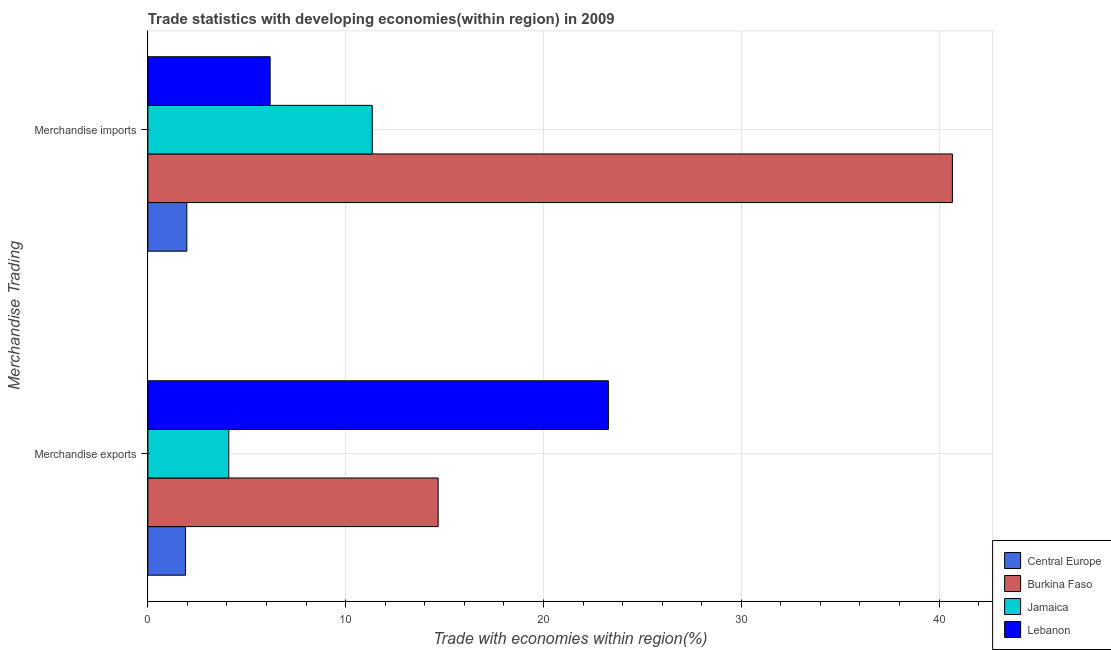How many groups of bars are there?
Offer a very short reply. 2. What is the label of the 1st group of bars from the top?
Keep it short and to the point. Merchandise imports. What is the merchandise exports in Central Europe?
Make the answer very short. 1.9. Across all countries, what is the maximum merchandise imports?
Provide a short and direct response. 40.67. Across all countries, what is the minimum merchandise imports?
Give a very brief answer. 1.97. In which country was the merchandise exports maximum?
Make the answer very short. Lebanon. In which country was the merchandise exports minimum?
Your response must be concise. Central Europe. What is the total merchandise imports in the graph?
Offer a terse response. 60.17. What is the difference between the merchandise exports in Lebanon and that in Central Europe?
Ensure brevity in your answer.  21.38. What is the difference between the merchandise exports in Jamaica and the merchandise imports in Lebanon?
Keep it short and to the point. -2.09. What is the average merchandise exports per country?
Offer a terse response. 10.99. What is the difference between the merchandise exports and merchandise imports in Burkina Faso?
Provide a short and direct response. -26. What is the ratio of the merchandise imports in Jamaica to that in Central Europe?
Your answer should be compact. 5.76. Is the merchandise imports in Jamaica less than that in Central Europe?
Offer a very short reply. No. What does the 2nd bar from the top in Merchandise exports represents?
Offer a terse response. Jamaica. What does the 1st bar from the bottom in Merchandise imports represents?
Your response must be concise. Central Europe. How many bars are there?
Make the answer very short. 8. Are all the bars in the graph horizontal?
Provide a short and direct response. Yes. How many countries are there in the graph?
Ensure brevity in your answer.  4. Does the graph contain grids?
Your answer should be compact. Yes. How many legend labels are there?
Your answer should be very brief. 4. What is the title of the graph?
Your answer should be compact. Trade statistics with developing economies(within region) in 2009. What is the label or title of the X-axis?
Give a very brief answer. Trade with economies within region(%). What is the label or title of the Y-axis?
Give a very brief answer. Merchandise Trading. What is the Trade with economies within region(%) in Central Europe in Merchandise exports?
Your answer should be very brief. 1.9. What is the Trade with economies within region(%) in Burkina Faso in Merchandise exports?
Ensure brevity in your answer.  14.67. What is the Trade with economies within region(%) of Jamaica in Merchandise exports?
Your answer should be very brief. 4.09. What is the Trade with economies within region(%) of Lebanon in Merchandise exports?
Make the answer very short. 23.28. What is the Trade with economies within region(%) of Central Europe in Merchandise imports?
Keep it short and to the point. 1.97. What is the Trade with economies within region(%) of Burkina Faso in Merchandise imports?
Ensure brevity in your answer.  40.67. What is the Trade with economies within region(%) in Jamaica in Merchandise imports?
Provide a succinct answer. 11.34. What is the Trade with economies within region(%) in Lebanon in Merchandise imports?
Give a very brief answer. 6.18. Across all Merchandise Trading, what is the maximum Trade with economies within region(%) in Central Europe?
Make the answer very short. 1.97. Across all Merchandise Trading, what is the maximum Trade with economies within region(%) of Burkina Faso?
Your answer should be very brief. 40.67. Across all Merchandise Trading, what is the maximum Trade with economies within region(%) of Jamaica?
Offer a very short reply. 11.34. Across all Merchandise Trading, what is the maximum Trade with economies within region(%) in Lebanon?
Offer a terse response. 23.28. Across all Merchandise Trading, what is the minimum Trade with economies within region(%) of Central Europe?
Give a very brief answer. 1.9. Across all Merchandise Trading, what is the minimum Trade with economies within region(%) of Burkina Faso?
Provide a short and direct response. 14.67. Across all Merchandise Trading, what is the minimum Trade with economies within region(%) in Jamaica?
Provide a succinct answer. 4.09. Across all Merchandise Trading, what is the minimum Trade with economies within region(%) in Lebanon?
Make the answer very short. 6.18. What is the total Trade with economies within region(%) in Central Europe in the graph?
Keep it short and to the point. 3.87. What is the total Trade with economies within region(%) in Burkina Faso in the graph?
Provide a short and direct response. 55.35. What is the total Trade with economies within region(%) in Jamaica in the graph?
Your answer should be very brief. 15.43. What is the total Trade with economies within region(%) of Lebanon in the graph?
Keep it short and to the point. 29.46. What is the difference between the Trade with economies within region(%) in Central Europe in Merchandise exports and that in Merchandise imports?
Make the answer very short. -0.07. What is the difference between the Trade with economies within region(%) in Burkina Faso in Merchandise exports and that in Merchandise imports?
Keep it short and to the point. -26. What is the difference between the Trade with economies within region(%) in Jamaica in Merchandise exports and that in Merchandise imports?
Provide a short and direct response. -7.25. What is the difference between the Trade with economies within region(%) of Lebanon in Merchandise exports and that in Merchandise imports?
Ensure brevity in your answer.  17.1. What is the difference between the Trade with economies within region(%) of Central Europe in Merchandise exports and the Trade with economies within region(%) of Burkina Faso in Merchandise imports?
Provide a succinct answer. -38.77. What is the difference between the Trade with economies within region(%) of Central Europe in Merchandise exports and the Trade with economies within region(%) of Jamaica in Merchandise imports?
Your answer should be very brief. -9.44. What is the difference between the Trade with economies within region(%) of Central Europe in Merchandise exports and the Trade with economies within region(%) of Lebanon in Merchandise imports?
Offer a terse response. -4.28. What is the difference between the Trade with economies within region(%) in Burkina Faso in Merchandise exports and the Trade with economies within region(%) in Jamaica in Merchandise imports?
Your response must be concise. 3.33. What is the difference between the Trade with economies within region(%) of Burkina Faso in Merchandise exports and the Trade with economies within region(%) of Lebanon in Merchandise imports?
Offer a terse response. 8.49. What is the difference between the Trade with economies within region(%) in Jamaica in Merchandise exports and the Trade with economies within region(%) in Lebanon in Merchandise imports?
Your response must be concise. -2.09. What is the average Trade with economies within region(%) of Central Europe per Merchandise Trading?
Give a very brief answer. 1.94. What is the average Trade with economies within region(%) in Burkina Faso per Merchandise Trading?
Give a very brief answer. 27.67. What is the average Trade with economies within region(%) of Jamaica per Merchandise Trading?
Keep it short and to the point. 7.72. What is the average Trade with economies within region(%) of Lebanon per Merchandise Trading?
Give a very brief answer. 14.73. What is the difference between the Trade with economies within region(%) in Central Europe and Trade with economies within region(%) in Burkina Faso in Merchandise exports?
Provide a succinct answer. -12.77. What is the difference between the Trade with economies within region(%) of Central Europe and Trade with economies within region(%) of Jamaica in Merchandise exports?
Offer a terse response. -2.19. What is the difference between the Trade with economies within region(%) of Central Europe and Trade with economies within region(%) of Lebanon in Merchandise exports?
Ensure brevity in your answer.  -21.38. What is the difference between the Trade with economies within region(%) of Burkina Faso and Trade with economies within region(%) of Jamaica in Merchandise exports?
Keep it short and to the point. 10.58. What is the difference between the Trade with economies within region(%) in Burkina Faso and Trade with economies within region(%) in Lebanon in Merchandise exports?
Provide a short and direct response. -8.61. What is the difference between the Trade with economies within region(%) in Jamaica and Trade with economies within region(%) in Lebanon in Merchandise exports?
Give a very brief answer. -19.19. What is the difference between the Trade with economies within region(%) of Central Europe and Trade with economies within region(%) of Burkina Faso in Merchandise imports?
Offer a terse response. -38.71. What is the difference between the Trade with economies within region(%) in Central Europe and Trade with economies within region(%) in Jamaica in Merchandise imports?
Provide a succinct answer. -9.37. What is the difference between the Trade with economies within region(%) in Central Europe and Trade with economies within region(%) in Lebanon in Merchandise imports?
Provide a short and direct response. -4.21. What is the difference between the Trade with economies within region(%) of Burkina Faso and Trade with economies within region(%) of Jamaica in Merchandise imports?
Give a very brief answer. 29.33. What is the difference between the Trade with economies within region(%) of Burkina Faso and Trade with economies within region(%) of Lebanon in Merchandise imports?
Provide a short and direct response. 34.49. What is the difference between the Trade with economies within region(%) in Jamaica and Trade with economies within region(%) in Lebanon in Merchandise imports?
Your response must be concise. 5.16. What is the ratio of the Trade with economies within region(%) in Central Europe in Merchandise exports to that in Merchandise imports?
Your response must be concise. 0.97. What is the ratio of the Trade with economies within region(%) of Burkina Faso in Merchandise exports to that in Merchandise imports?
Your response must be concise. 0.36. What is the ratio of the Trade with economies within region(%) in Jamaica in Merchandise exports to that in Merchandise imports?
Offer a very short reply. 0.36. What is the ratio of the Trade with economies within region(%) in Lebanon in Merchandise exports to that in Merchandise imports?
Offer a very short reply. 3.77. What is the difference between the highest and the second highest Trade with economies within region(%) of Central Europe?
Offer a terse response. 0.07. What is the difference between the highest and the second highest Trade with economies within region(%) of Burkina Faso?
Offer a very short reply. 26. What is the difference between the highest and the second highest Trade with economies within region(%) in Jamaica?
Offer a terse response. 7.25. What is the difference between the highest and the second highest Trade with economies within region(%) of Lebanon?
Your answer should be compact. 17.1. What is the difference between the highest and the lowest Trade with economies within region(%) in Central Europe?
Provide a short and direct response. 0.07. What is the difference between the highest and the lowest Trade with economies within region(%) of Burkina Faso?
Provide a succinct answer. 26. What is the difference between the highest and the lowest Trade with economies within region(%) in Jamaica?
Provide a succinct answer. 7.25. What is the difference between the highest and the lowest Trade with economies within region(%) in Lebanon?
Offer a terse response. 17.1. 